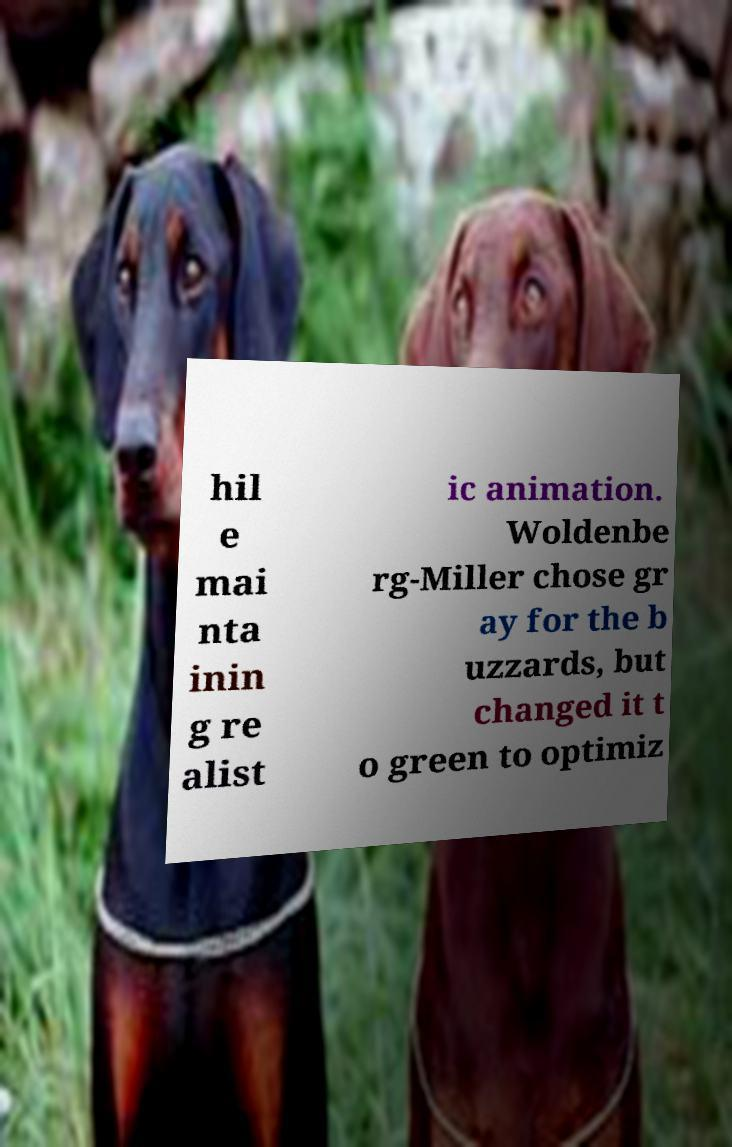Please read and relay the text visible in this image. What does it say? hil e mai nta inin g re alist ic animation. Woldenbe rg-Miller chose gr ay for the b uzzards, but changed it t o green to optimiz 